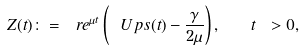Convert formula to latex. <formula><loc_0><loc_0><loc_500><loc_500>Z ( t ) \colon = \ r e ^ { \mu t } \left ( \ U p s ( t ) - \frac { \gamma } { 2 \mu } \right ) , \quad t \ > 0 ,</formula> 